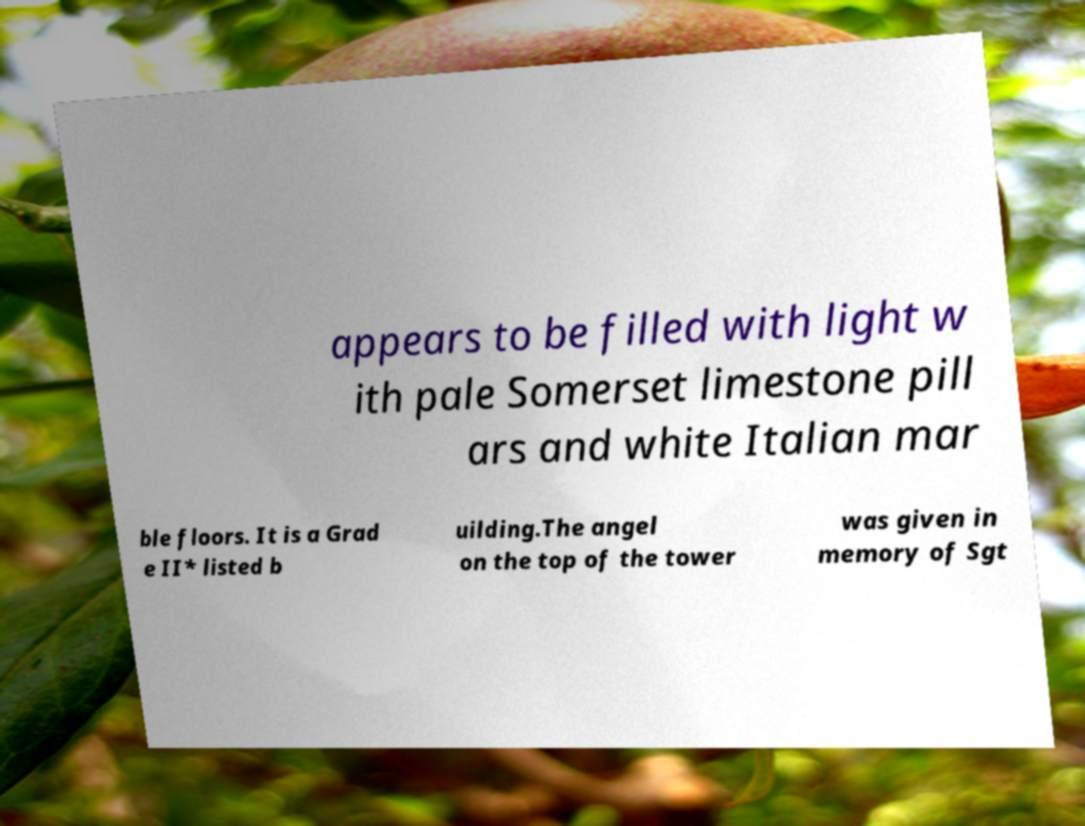I need the written content from this picture converted into text. Can you do that? appears to be filled with light w ith pale Somerset limestone pill ars and white Italian mar ble floors. It is a Grad e II* listed b uilding.The angel on the top of the tower was given in memory of Sgt 